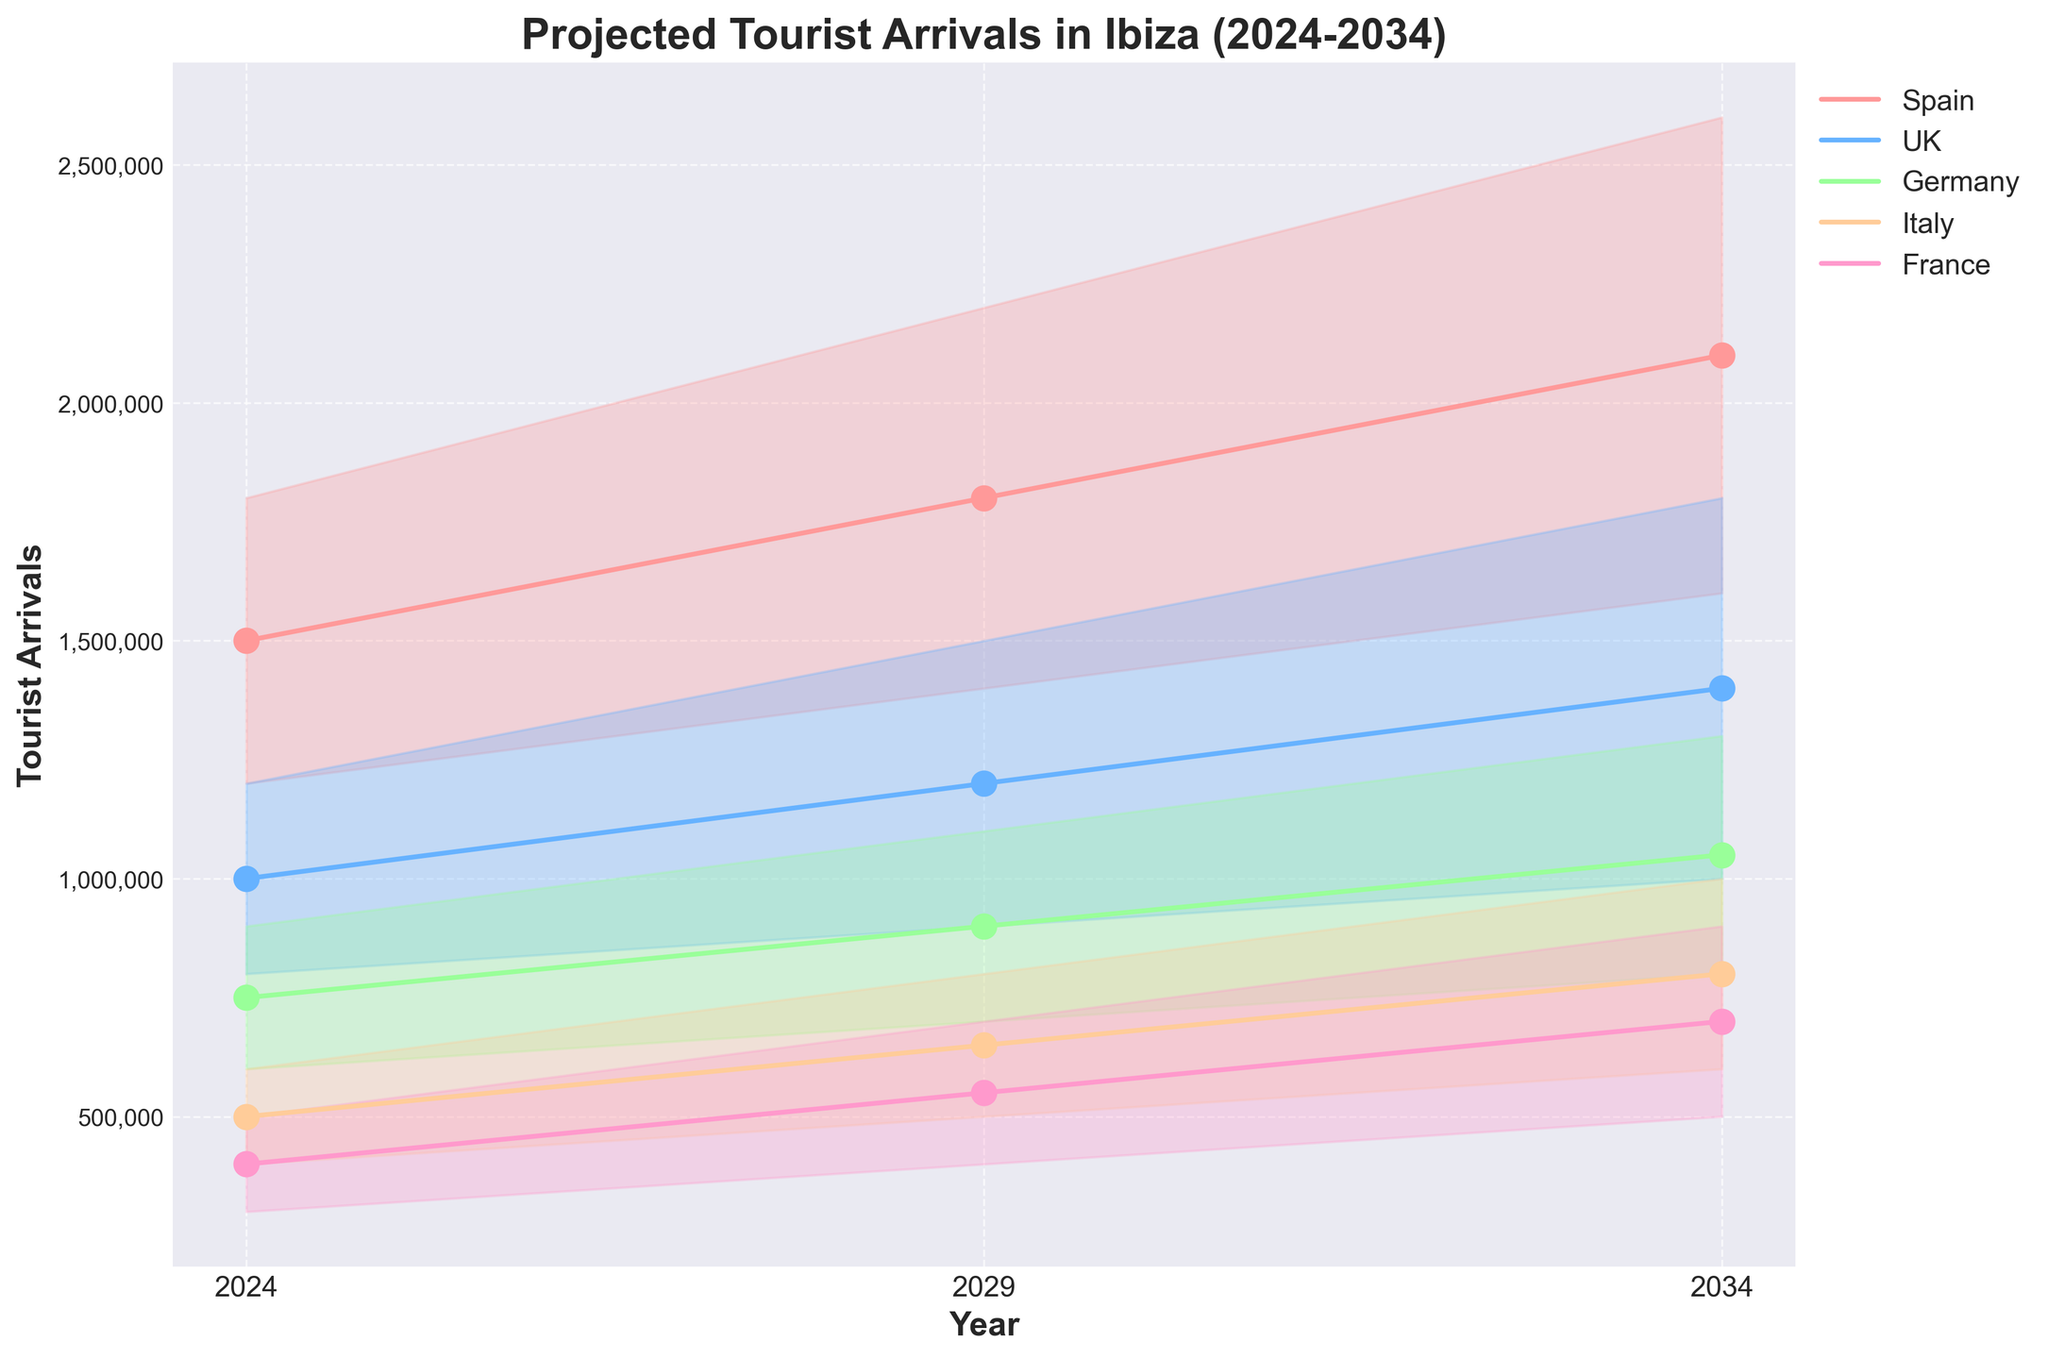What is the expected range of tourist arrivals from Spain in 2024? The range includes the lowest and highest projected tourist arrivals from Spain in 2024, which are 1,200,000 and 1,800,000, respectively.
Answer: 1,200,000 - 1,800,000 Which year shows the highest mid-level projected tourist arrivals from the UK? By examining the mid-level projections for the UK in the years given, 1,400,000 in 2034 is the highest.
Answer: 2034 How much is the growth in mid-level projected tourist arrivals from France between 2024 and 2029? Subtract the mid-level figure for France in 2024 (400,000) from that in 2029 (550,000), results in a growth of 150,000 arrivals.
Answer: 150,000 What is the total mid-level projected tourist arrivals for all listed countries in 2029? Sum the mid-level projections for each country in 2029: Spain (1,800,000) + UK (1,200,000) + Germany (900,000) + Italy (650,000) + France (550,000) = 5,100,000.
Answer: 5,100,000 For which country does the projected range of tourist arrivals seem to widen the most between 2024 and 2034? Comparing the difference between high and low projections for each country in 2024 and 2034, Spain's range widens the most from (600,000 in 2024 to 1,000,000 in 2034).
Answer: Spain By how much do the high projections for German tourist arrivals increase from 2024 to 2034? Subtracting the high projection for Germany in 2024 (900,000) from that in 2034 (1,300,000) results in an increase of 400,000 arrivals.
Answer: 400,000 Which country has the smallest projected increase in mid-level tourist arrivals from 2024 to 2034? Checking the mid-level projections, France has the smallest increase, growing from 400,000 in 2024 to 700,000 in 2034, an increase of 300,000.
Answer: France Does Italy's projected tourist arrival midpoint surpass 700,000 at any time before 2034? Italy's mid-level projections are reviewed for 2024 (500,000), 2029 (650,000), and 2034 (800,000), which shows the midpoint does not surpass 700,000 before 2034.
Answer: No What is the difference in high-level projections for Spanish tourist arrivals between 2024 and 2029? Subtracting the high projection for Spain in 2024 (1,800,000) from that in 2029 (2,200,000) results in a difference of 400,000.
Answer: 400,000 How does the projected growth in tourist arrivals from the UK compare to Germany between 2024 and 2034? Calculating the mid-level projections: UK's increases from 1,000,000 to 1,400,000 (growth of 400,000), and Germany's increase from 750,000 to 1,050,000 (growth of 300,000). UK's projected growth is higher.
Answer: UK’s growth is higher 